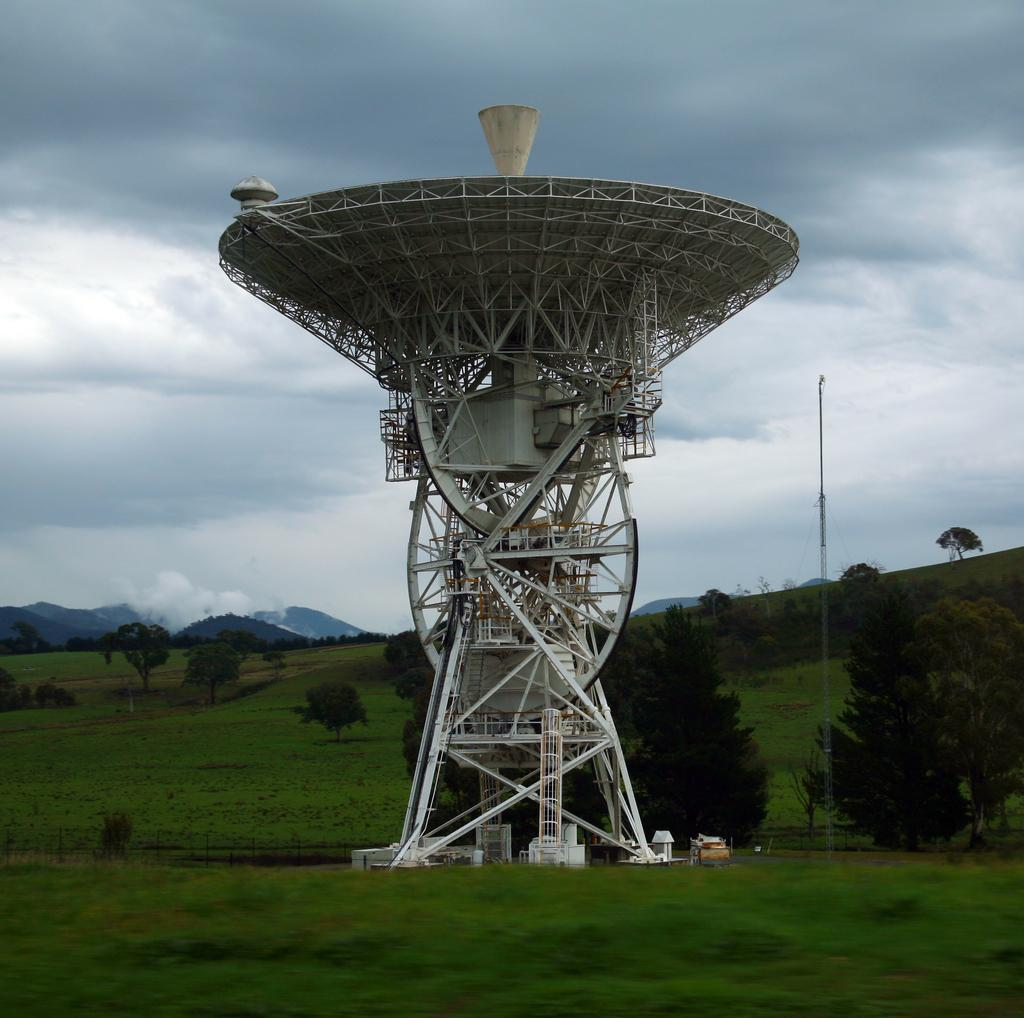What is the main structure in the image? There is a tower with rods in the image. Where is the tower located? The tower is on a grass lawn. What can be seen in the background of the image? There are trees, a pole, the sky, clouds, and hills visible in the background of the image. Can you tell me how many babies are crawling on the grass lawn in the image? There are no babies present in the image; it features a tower with rods on a grass lawn. What type of wire is connected to the tower in the image? There is no wire connected to the tower in the image; it only has rods. 